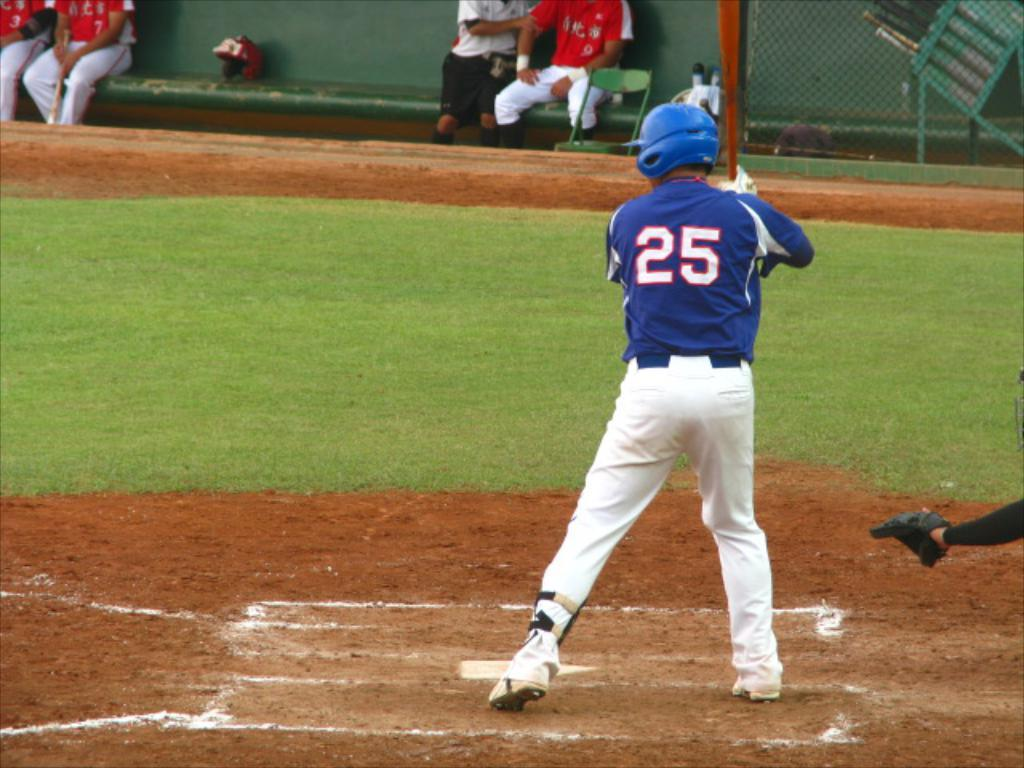<image>
Give a short and clear explanation of the subsequent image. a person with the number 25 on their jersey 